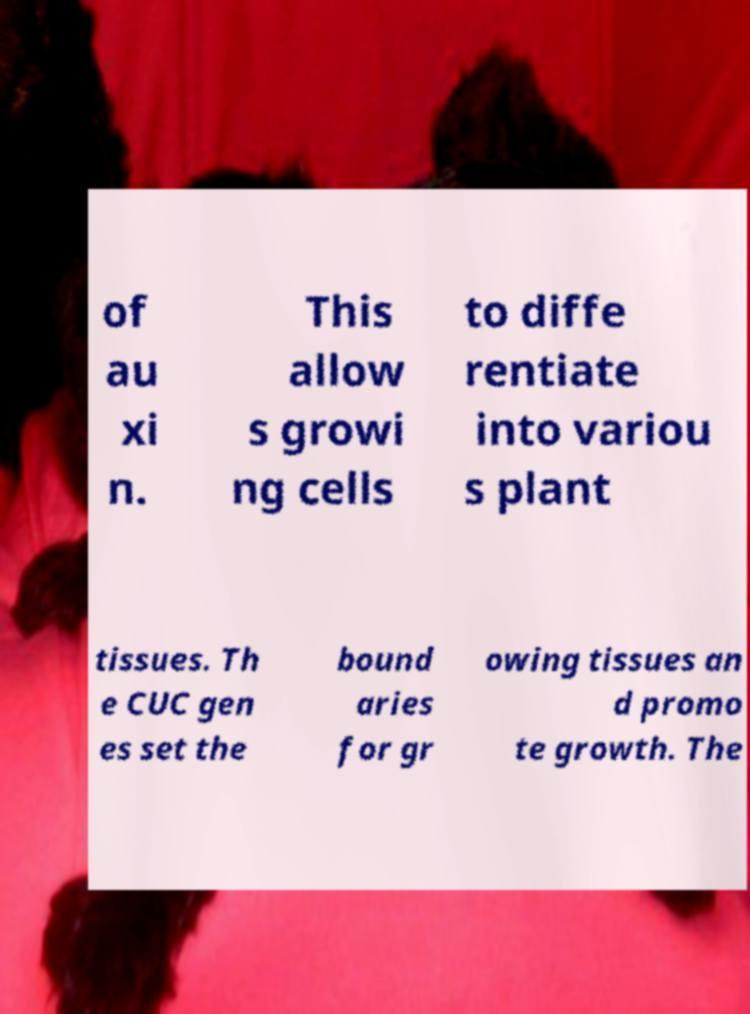Could you extract and type out the text from this image? of au xi n. This allow s growi ng cells to diffe rentiate into variou s plant tissues. Th e CUC gen es set the bound aries for gr owing tissues an d promo te growth. The 